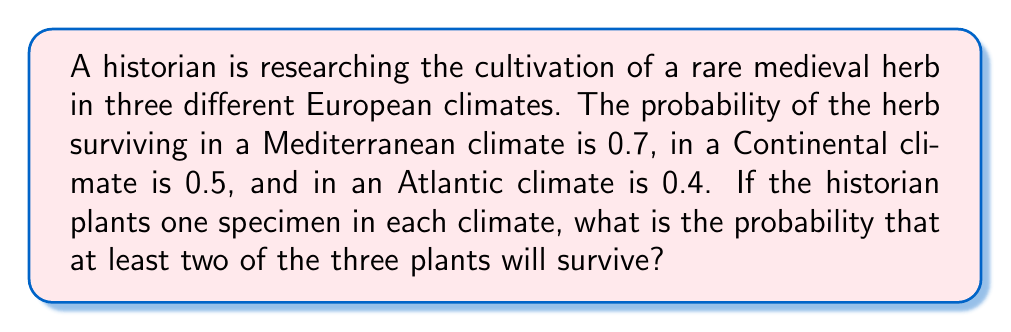Give your solution to this math problem. Let's approach this step-by-step:

1) First, we need to calculate the probability of different survival scenarios. Let's use M, C, and A to represent survival in Mediterranean, Continental, and Atlantic climates respectively.

2) The probability of all three plants surviving is:
   $P(M \cap C \cap A) = 0.7 \times 0.5 \times 0.4 = 0.14$

3) The probability of exactly two plants surviving:
   $P(M \cap C \cap \text{not}A) = 0.7 \times 0.5 \times 0.6 = 0.21$
   $P(M \cap \text{not}C \cap A) = 0.7 \times 0.5 \times 0.4 = 0.14$
   $P(\text{not}M \cap C \cap A) = 0.3 \times 0.5 \times 0.4 = 0.06$

4) The total probability of exactly two plants surviving is the sum of these:
   $P(\text{exactly two}) = 0.21 + 0.14 + 0.06 = 0.41$

5) The probability of at least two plants surviving is the sum of the probability of all three surviving and exactly two surviving:
   $P(\text{at least two}) = P(\text{all three}) + P(\text{exactly two})$
   $P(\text{at least two}) = 0.14 + 0.41 = 0.55$

6) Therefore, the probability that at least two of the three plants will survive is 0.55 or 55%.
Answer: 0.55 